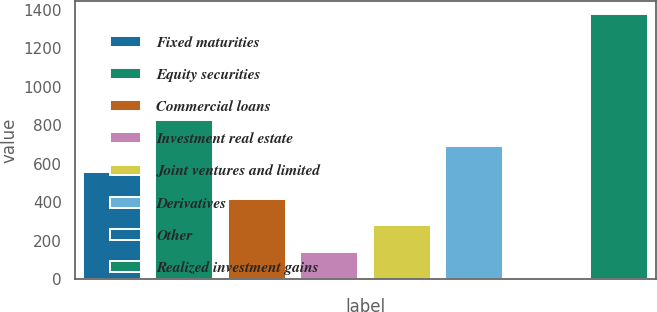Convert chart. <chart><loc_0><loc_0><loc_500><loc_500><bar_chart><fcel>Fixed maturities<fcel>Equity securities<fcel>Commercial loans<fcel>Investment real estate<fcel>Joint ventures and limited<fcel>Derivatives<fcel>Other<fcel>Realized investment gains<nl><fcel>553.6<fcel>828.4<fcel>416.2<fcel>141.4<fcel>278.8<fcel>691<fcel>4<fcel>1378<nl></chart> 